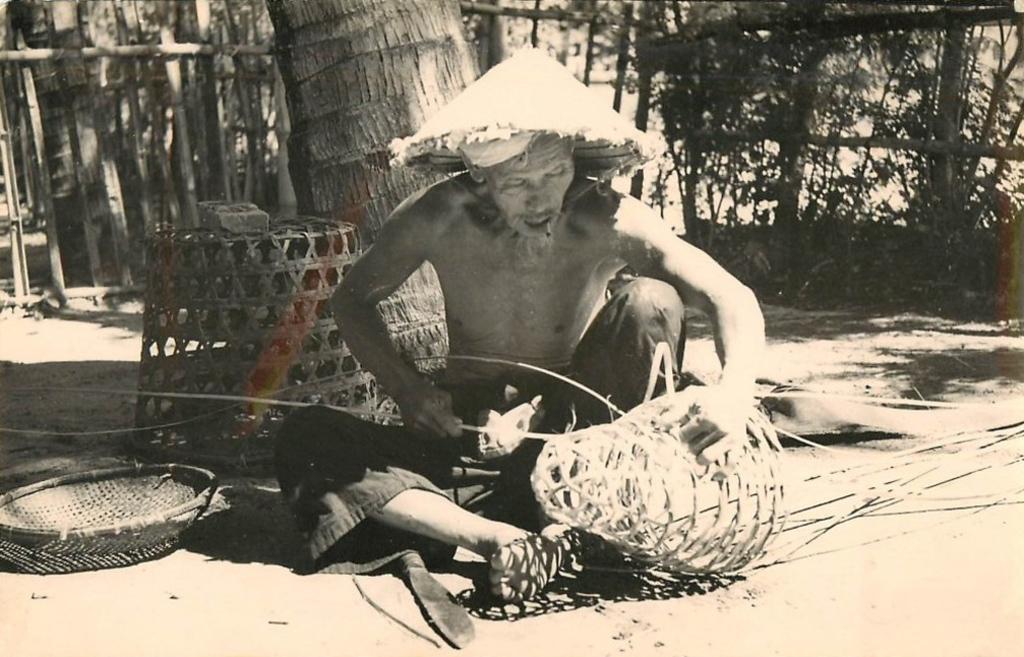In one or two sentences, can you explain what this image depicts? This is a black and white picture. The man in the middle of the picture is sitting on the floor. He is weaving the basket. Beside him, we see the baskets. Behind him, we see the stem of the tree. In the background, we see a wooden fence and trees. 